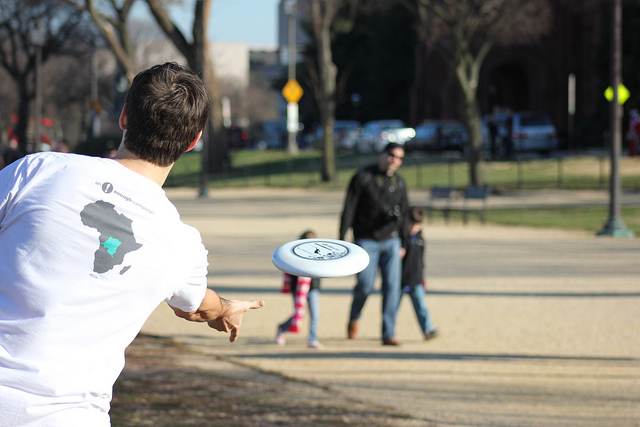What time of day does it appear to be in the photograph? Observing the shadows and the quality of light, it seems to be on a bright, sunny day, likely late morning or early afternoon. 